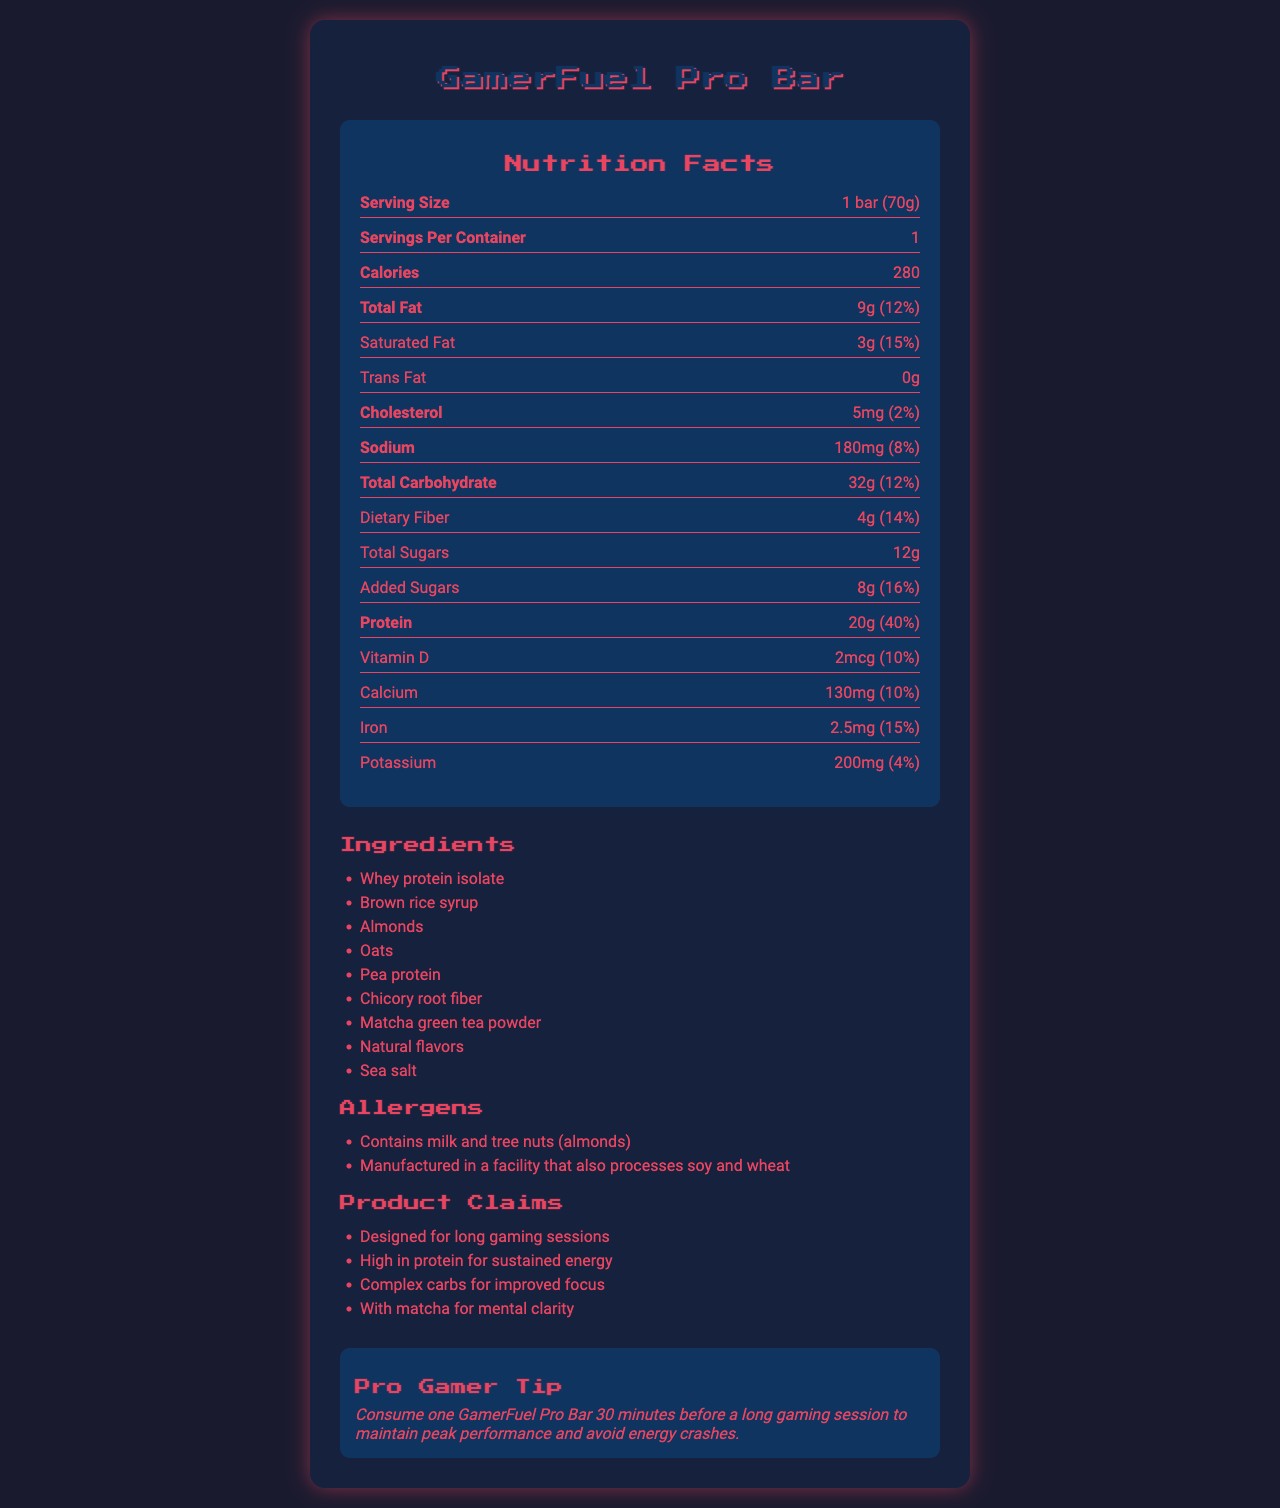what is the serving size of the GamerFuel Pro Bar? The serving size is listed at the top of the nutrition facts as "1 bar (70g)".
Answer: 1 bar (70g) how many calories are there per serving? The calories per serving are mentioned as "280" in the nutrition facts section.
Answer: 280 what is the total carbohydrate content per serving? The total carbohydrate content per serving is listed as "32g (12%)".
Answer: 32g how much protein does the GamerFuel Pro Bar contain per serving? The protein content per serving is "20g (40%)".
Answer: 20g which two ingredients are highlighted in the allergen information? The allergen section states "Contains milk and tree nuts (almonds)".
Answer: Milk and tree nuts (almonds) the GamerFuel Pro Bar contains matcha. The ingredients list includes "Matcha green tea powder".
Answer: True What is the cholesterol content in one bar? The nutrition facts show cholesterol content as "5mg (2%)".
Answer: 5mg (2%) Which ingredient is first on the list for the GamerFuel Pro Bar? A. Brown rice syrup B. Almonds C. Whey protein isolate D. Oats The first ingredient listed is "Whey protein isolate".
Answer: C. Whey protein isolate How much dietary fiber is there in the bar? A. 2g B. 4g C. 6g D. 8g The nutrition facts listed dietary fiber as "4g (14%)".
Answer: B. 4g Was the bar designed to enhance mental clarity? One of the marketing claims states "With matcha for mental clarity".
Answer: Yes Summarize the main purpose and nutritional benefits of the GamerFuel Pro Bar The entire document emphasizes that the bar is meant for gamers, highlighting its high protein and carbohydrate content for sustained energy, matcha for mental clarity, and other nutrients that contribute to overall performance during long gaming sessions.
Answer: The GamerFuel Pro Bar is designed specifically for long gaming sessions. It provides sustained energy through high protein content and complex carbohydrates, includes matcha for mental clarity, and contains essential vitamins and minerals. Does the document contain the manufacturing process details? The document does not provide any details related to the manufacturing process of the GamerFuel Pro Bar.
Answer: Not enough information 